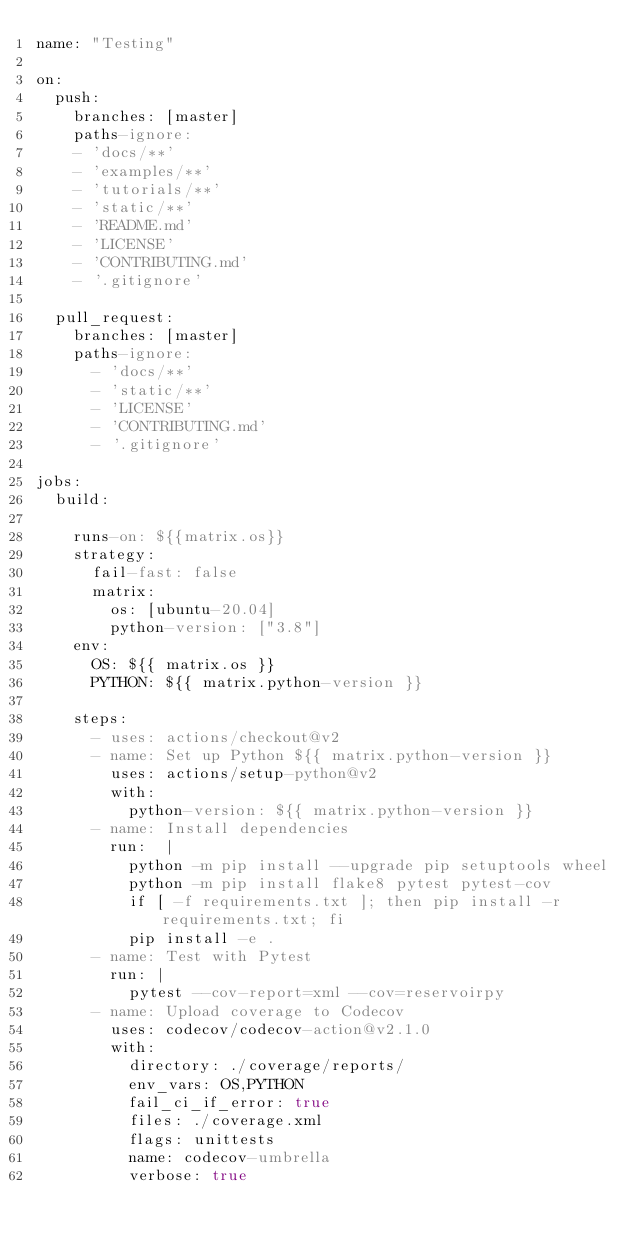Convert code to text. <code><loc_0><loc_0><loc_500><loc_500><_YAML_>name: "Testing"

on:
  push:
    branches: [master]
    paths-ignore:
    - 'docs/**'
    - 'examples/**'
    - 'tutorials/**'
    - 'static/**'
    - 'README.md'
    - 'LICENSE'
    - 'CONTRIBUTING.md'
    - '.gitignore'

  pull_request:
    branches: [master]
    paths-ignore:
      - 'docs/**'
      - 'static/**'
      - 'LICENSE'
      - 'CONTRIBUTING.md'
      - '.gitignore'

jobs:
  build:

    runs-on: ${{matrix.os}}
    strategy:
      fail-fast: false
      matrix:
        os: [ubuntu-20.04]
        python-version: ["3.8"]
    env:
      OS: ${{ matrix.os }}
      PYTHON: ${{ matrix.python-version }}

    steps:
      - uses: actions/checkout@v2
      - name: Set up Python ${{ matrix.python-version }}
        uses: actions/setup-python@v2
        with:
          python-version: ${{ matrix.python-version }}
      - name: Install dependencies
        run:  |
          python -m pip install --upgrade pip setuptools wheel
          python -m pip install flake8 pytest pytest-cov
          if [ -f requirements.txt ]; then pip install -r requirements.txt; fi
          pip install -e .
      - name: Test with Pytest
        run: |
          pytest --cov-report=xml --cov=reservoirpy
      - name: Upload coverage to Codecov
        uses: codecov/codecov-action@v2.1.0
        with:
          directory: ./coverage/reports/
          env_vars: OS,PYTHON
          fail_ci_if_error: true
          files: ./coverage.xml
          flags: unittests
          name: codecov-umbrella
          verbose: true
</code> 